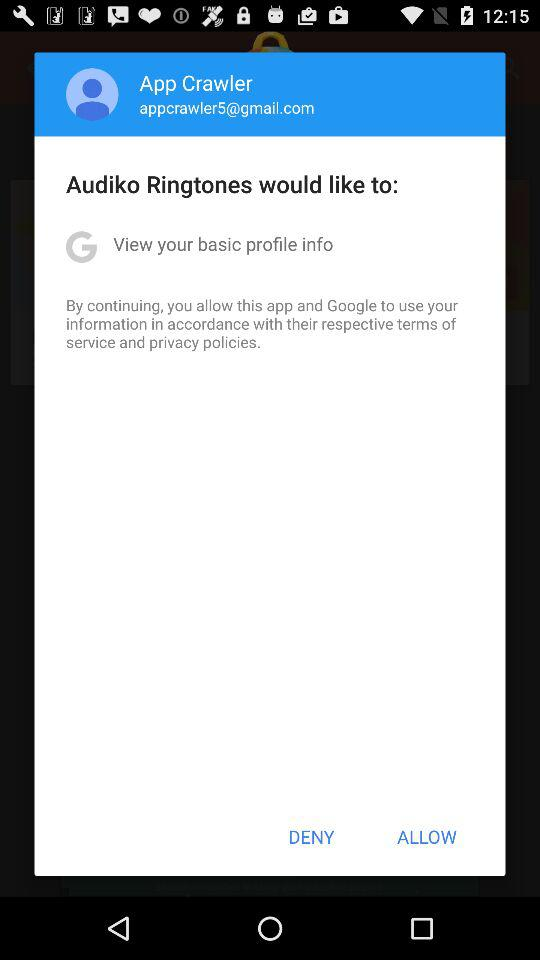What is the name of the user? The name of the user is App Crawler. 